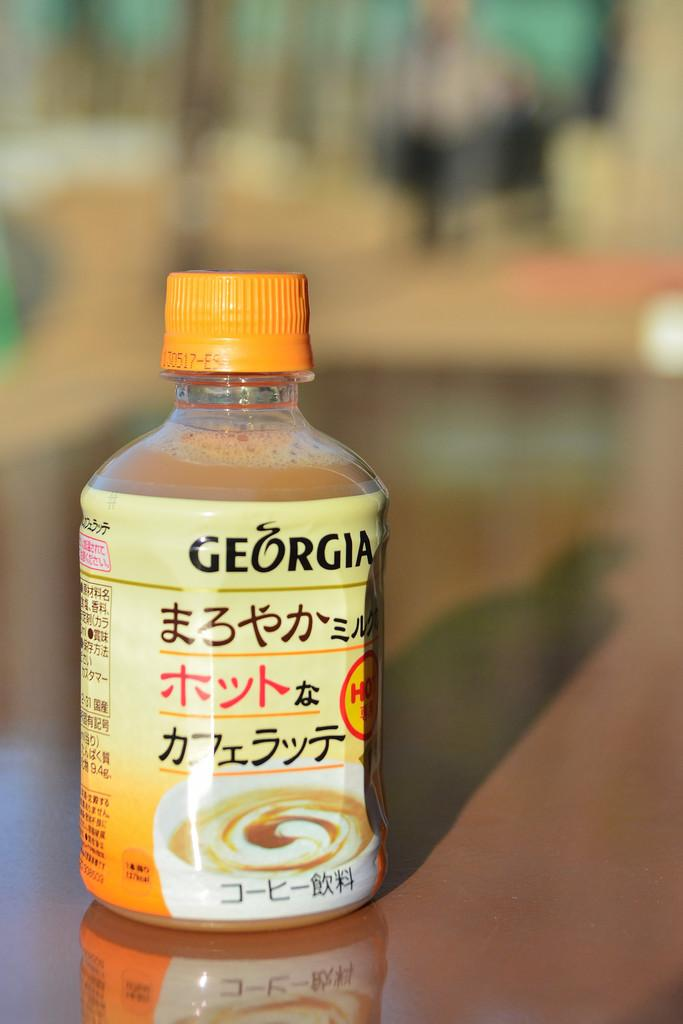What is the color of the cap on the bottle in the image? The cap on the bottle in the image is orange. Where is the bottle located in the image? The bottle is on a table in the image. Can you describe the background of the image? The background of the image is blurred. How many flowers are on the base of the bottle in the image? There are no flowers present in the image, and the bottle does not have a base. 